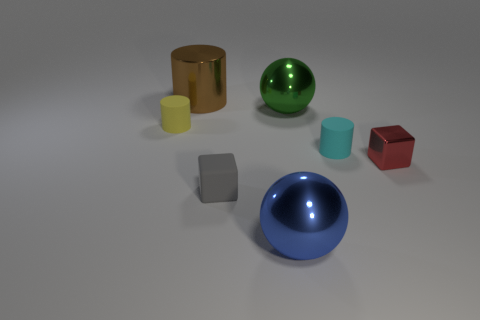There is a brown object that is the same material as the big green sphere; what size is it?
Make the answer very short. Large. What shape is the big metal thing in front of the big sphere that is behind the cyan cylinder?
Ensure brevity in your answer.  Sphere. How many brown things are metallic cylinders or tiny rubber cylinders?
Keep it short and to the point. 1. There is a small cylinder behind the small cylinder on the right side of the brown metal cylinder; is there a object that is to the right of it?
Give a very brief answer. Yes. What number of small objects are either yellow matte balls or yellow matte cylinders?
Ensure brevity in your answer.  1. Do the tiny matte thing that is in front of the red metal block and the small red object have the same shape?
Give a very brief answer. Yes. Is the number of large brown cylinders less than the number of big cyan metallic spheres?
Offer a terse response. No. The thing that is to the left of the big brown cylinder has what shape?
Your answer should be very brief. Cylinder. Are there the same number of tiny rubber blocks behind the matte cube and objects behind the tiny shiny block?
Offer a very short reply. No. What number of other objects are there of the same size as the blue metal sphere?
Provide a succinct answer. 2. 